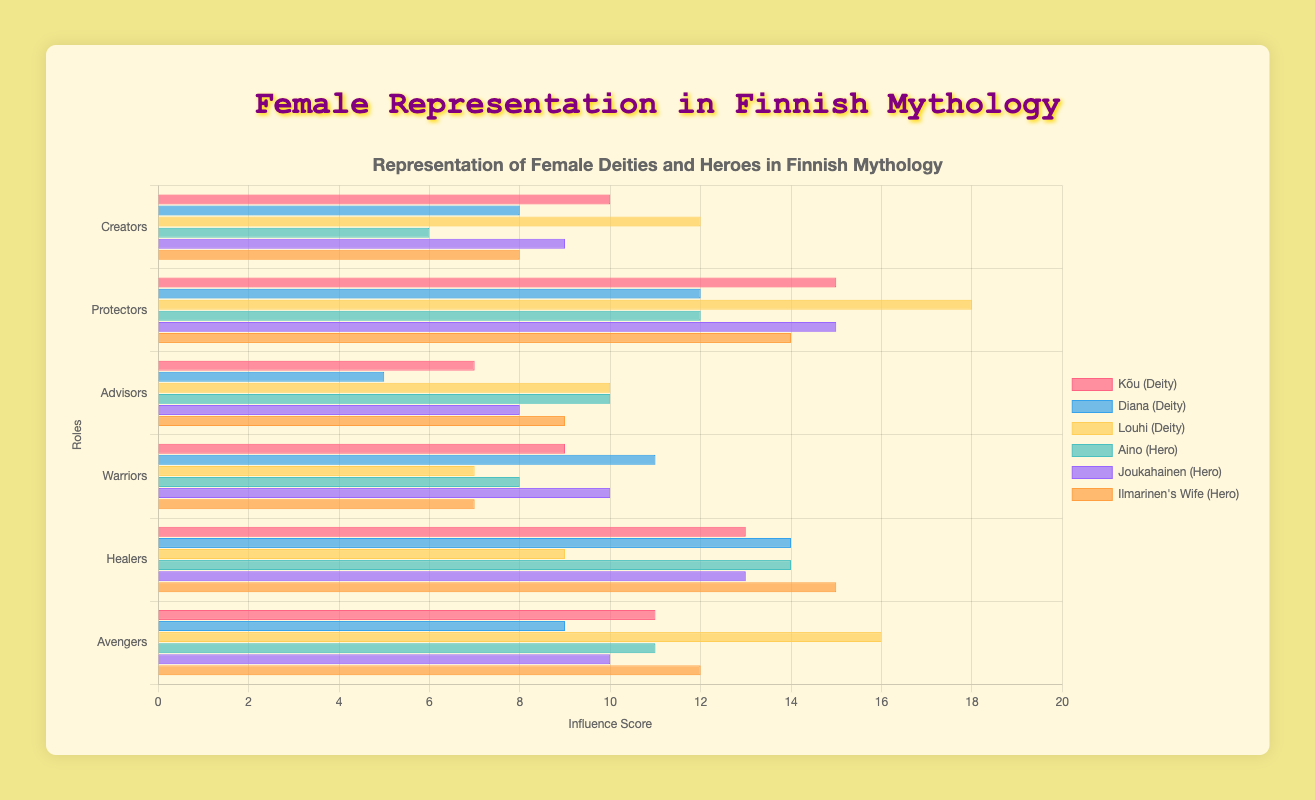Which role has the highest influence score for Louhi as a deity? Look at the bars representing Louhi in each role; the tallest bar indicates the highest influence score. Louhi has the highest influence score in the "Protectors" role.
Answer: Protectors What is the total influence score of Diana in all roles combined? Add the influence scores of Diana across all roles: Creators (8) + Protectors (12) + Advisors (5) + Warriors (11) + Healers (14) + Avengers (9) = 59
Answer: 59 Who has a higher influence score in the "Warriors" role, Aino or Joukahainen? Compare the bars for Aino and Joukahainen in the "Warriors" role. Joukahainen has a higher influence score (10) compared to Aino (8).
Answer: Joukahainen What is the average influence score of Kõu as a deity across all roles? Calculate the average by summing Kõu's scores and dividing by the number of roles: (Creators 10 + Protectors 15 + Advisors 7 + Warriors 9 + Healers 13 + Avengers 11) / 6 = 65 / 6 = 10.83
Answer: 10.83 Compare the role of Healers: who has the highest influence score among the deities and heroes? Look at the influence scores in the Healers role for both categories. Among the deities, Diana has the highest score (14). Among the heroes, Ilmarinen's Wife has the highest score (15).
Answer: Diana (Deities), Ilmarinen's Wife (Heroes) What is the difference in influence scores between Kõu and Louhi in the Creators role? Subtract Kõu's score from Louhi's score in the Creators role: Louhi (12) - Kõu (10) = 2
Answer: 2 Which hero has the smallest influence score in the Avengers role? Compare the bars for Aino, Joukahainen, and Ilmarinen's Wife in the Avengers role. Joukahainen has the smallest influence score (10).
Answer: Joukahainen For the role of Protectors, what is the combined influence score for all heroes? Add the influence scores for Aino, Joukahainen, and Ilmarinen's Wife in the Protectors role: Aino (12) + Joukahainen (15) + Ilmarinen's Wife (14) = 41
Answer: 41 How do the influence scores of Aino in the role of Warriors compare to her scores in the role of Advisors? Compare the influence score of Aino in the Warriors role (8) with the Advisors role (10). The score in the Advisors role is higher.
Answer: Advisors Which deity appears to have the most balanced distribution of influence scores across all roles? Look across the bars representing Kõu, Diana, and Louhi to see which deity has the most even heights. Kõu's scores are relatively balanced compared to the others.
Answer: Kõu 